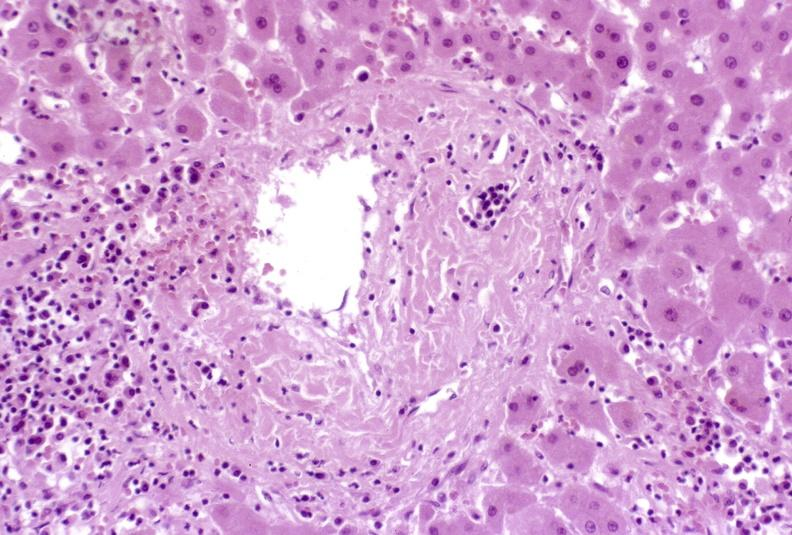s hypersegmented neutrophil present?
Answer the question using a single word or phrase. No 